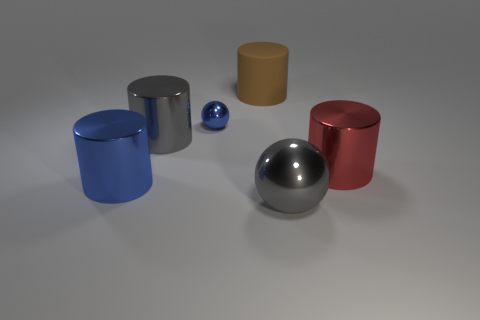Subtract all red balls. Subtract all brown cylinders. How many balls are left? 2 Add 2 metal balls. How many objects exist? 8 Subtract all spheres. How many objects are left? 4 Add 2 gray shiny things. How many gray shiny things are left? 4 Add 4 large metal things. How many large metal things exist? 8 Subtract 0 green cylinders. How many objects are left? 6 Subtract all large brown objects. Subtract all big gray balls. How many objects are left? 4 